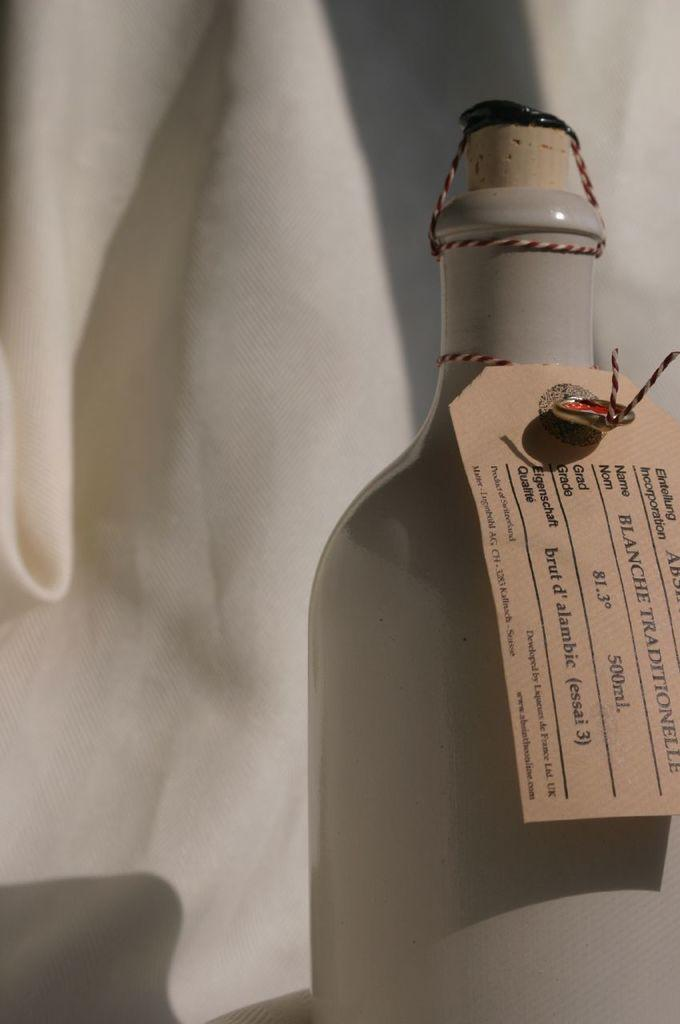<image>
Relay a brief, clear account of the picture shown. A bottle with the name blanche traditionelle on the tag 